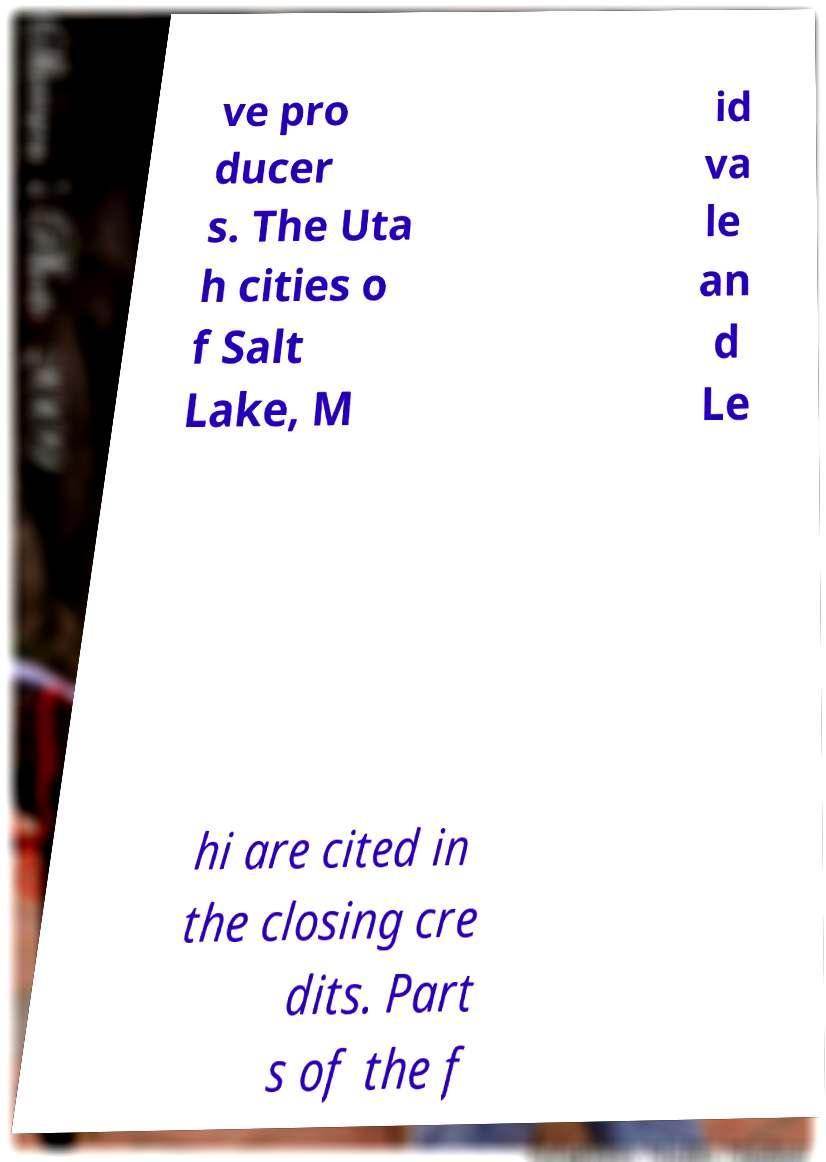Can you read and provide the text displayed in the image?This photo seems to have some interesting text. Can you extract and type it out for me? ve pro ducer s. The Uta h cities o f Salt Lake, M id va le an d Le hi are cited in the closing cre dits. Part s of the f 